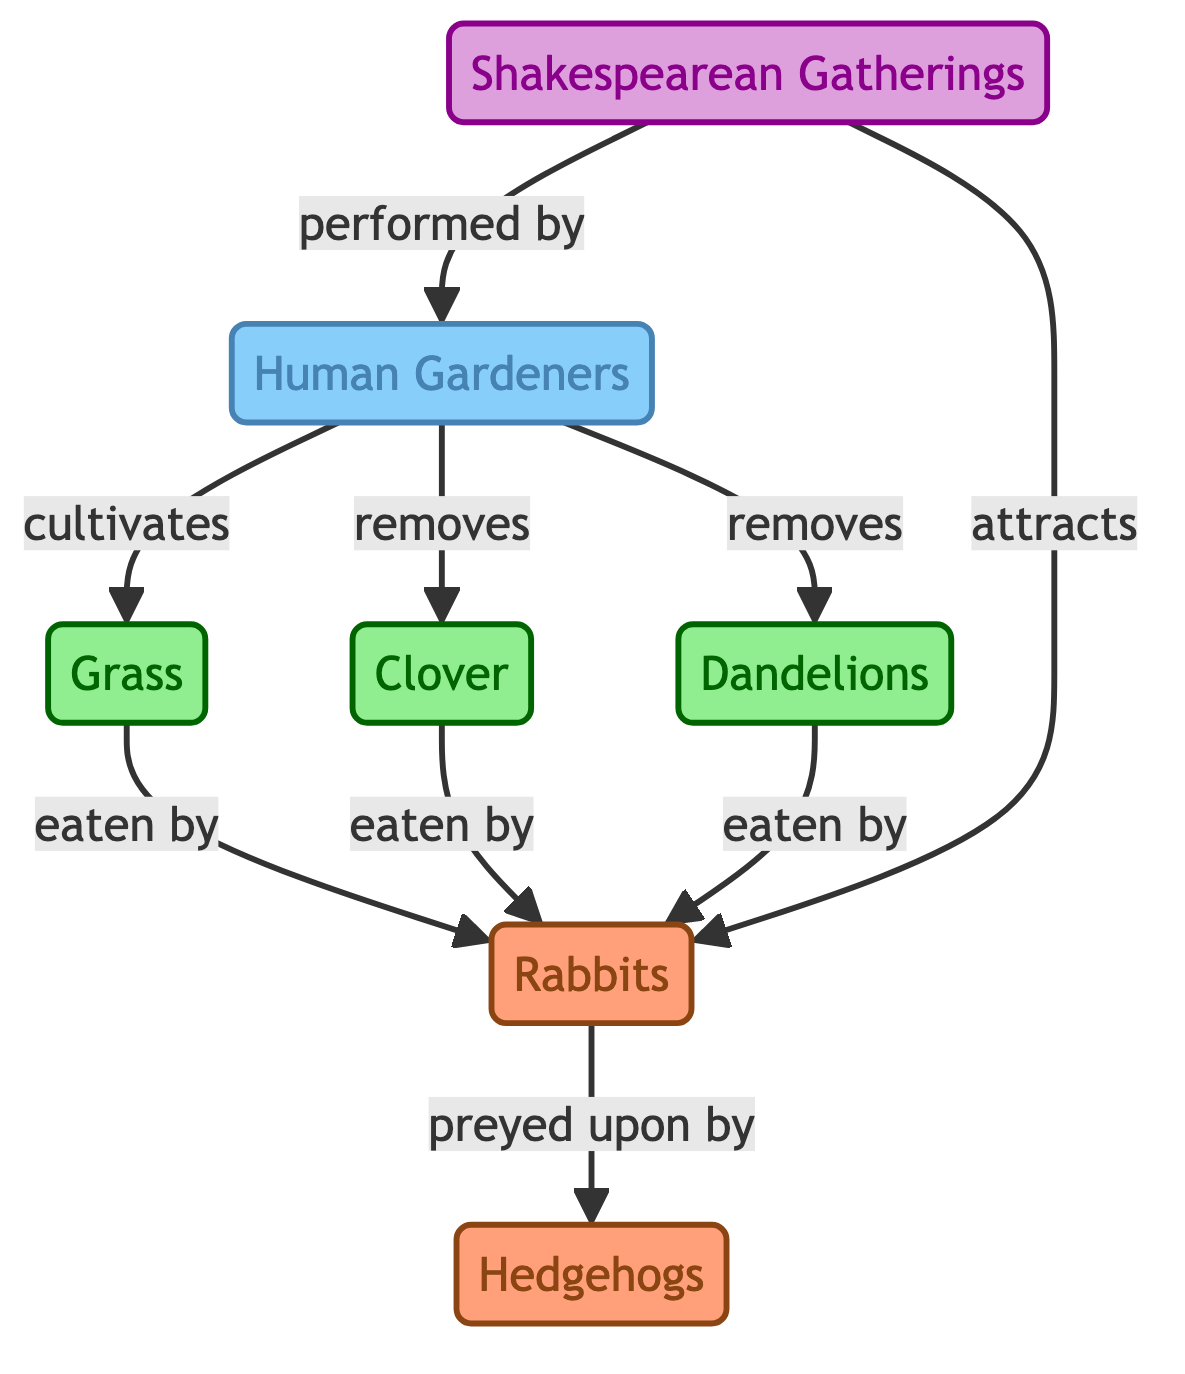What are the three types of plants shown in the diagram? The diagram lists three plant types: Grass, Clover, and Dandelions. These are clearly represented as nodes in the diagram, classified under the "plant" category.
Answer: Grass, Clover, Dandelions How many herbivores are there in the garden setting? The diagram shows that there is one herbivore, the Rabbits, which directly consumes the plants listed. Hedgehogs are present but are not herbivores as they prey on rabbits.
Answer: 1 Who cultivates the grass in the garden? The diagram indicates that Human Gardeners cultivate the depicted types of plants, indicating their active role in the garden's ecosystem.
Answer: Human Gardeners What do Shakespearean Gatherings attract? According to the diagram, Shakespearean Gatherings attract Rabbits, thus playing a role in the flow of interactions in the garden.
Answer: Rabbits What role do Hedgehogs play in this food chain? The Hedgehogs are indicated as predators that prey upon the Rabbits, thus serving a role in the food chain as a secondary consumer in this context.
Answer: Preyed upon by Which human action affects the Clover and Dandelions? The diagram states that Human Gardeners remove Clover and Dandelions, showing their impact on these specific plants in the garden.
Answer: Removes How many edges connect the Rabbits to other nodes? The Rabbits connect to two nodes: they are eaten by three types of plants and preyed upon by Hedgehogs. Thus, there are three connections going from plants to Rabbits and one to Hedgehogs, totaling four edges.
Answer: 4 Who performs at the Shakespearean Gatherings? The diagram shows Human Gardeners perform during Shakespearean Gatherings, linking human interaction with artistic expression in the garden.
Answer: Human Gardeners What is the effect of Shakespearean Gatherings on the garden? The diagram shows that Shakespearean Gatherings attract Rabbits, suggesting that these events have a role in drawing herbivores into the garden ecosystem, affecting their presence and dynamics.
Answer: Attracts Rabbits 